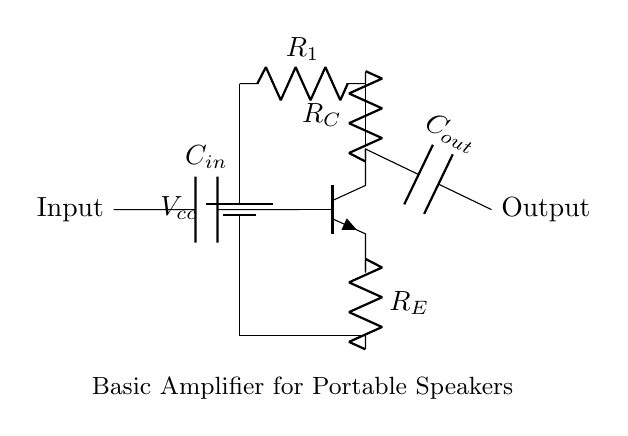What is the function of the capacitor labeled C_in? The capacitor C_in is used to block any DC components from the input signal while allowing AC signals to pass through to the base of the transistor, which is essential for amplifying audio signals.
Answer: Block DC What is the role of resistor R_E in this amplifier circuit? Resistor R_E provides stability to the amplifier by stabilizing the operating point, and it helps set the gain of the amplifier by providing negative feedback.
Answer: Stability How many resistors are present in the circuit? There are three resistors in the circuit: R_1, R_C, and R_E.
Answer: Three What type of transistor is used in this amplifier circuit? The circuit uses an NPN transistor, which is indicated by the npn symbol in the diagram.
Answer: NPN What is the purpose of capacitor C_out? The capacitor C_out is used to couple the amplified output signal to the load while blocking any DC component, ensuring that only the AC part of the signal is delivered to the speakers.
Answer: Couple output What does the battery represent in this circuit? The battery V_cc represents the power supply voltage required to operate the amplifier circuit, providing the necessary energy for signal amplification.
Answer: Power supply How are the input and output of the amplifier labeled in this circuit? The input is labeled on the left side and connects to C_in, while the output is on the right side connecting to C_out, clearly indicating their respective signal flow directions.
Answer: Input and Output 